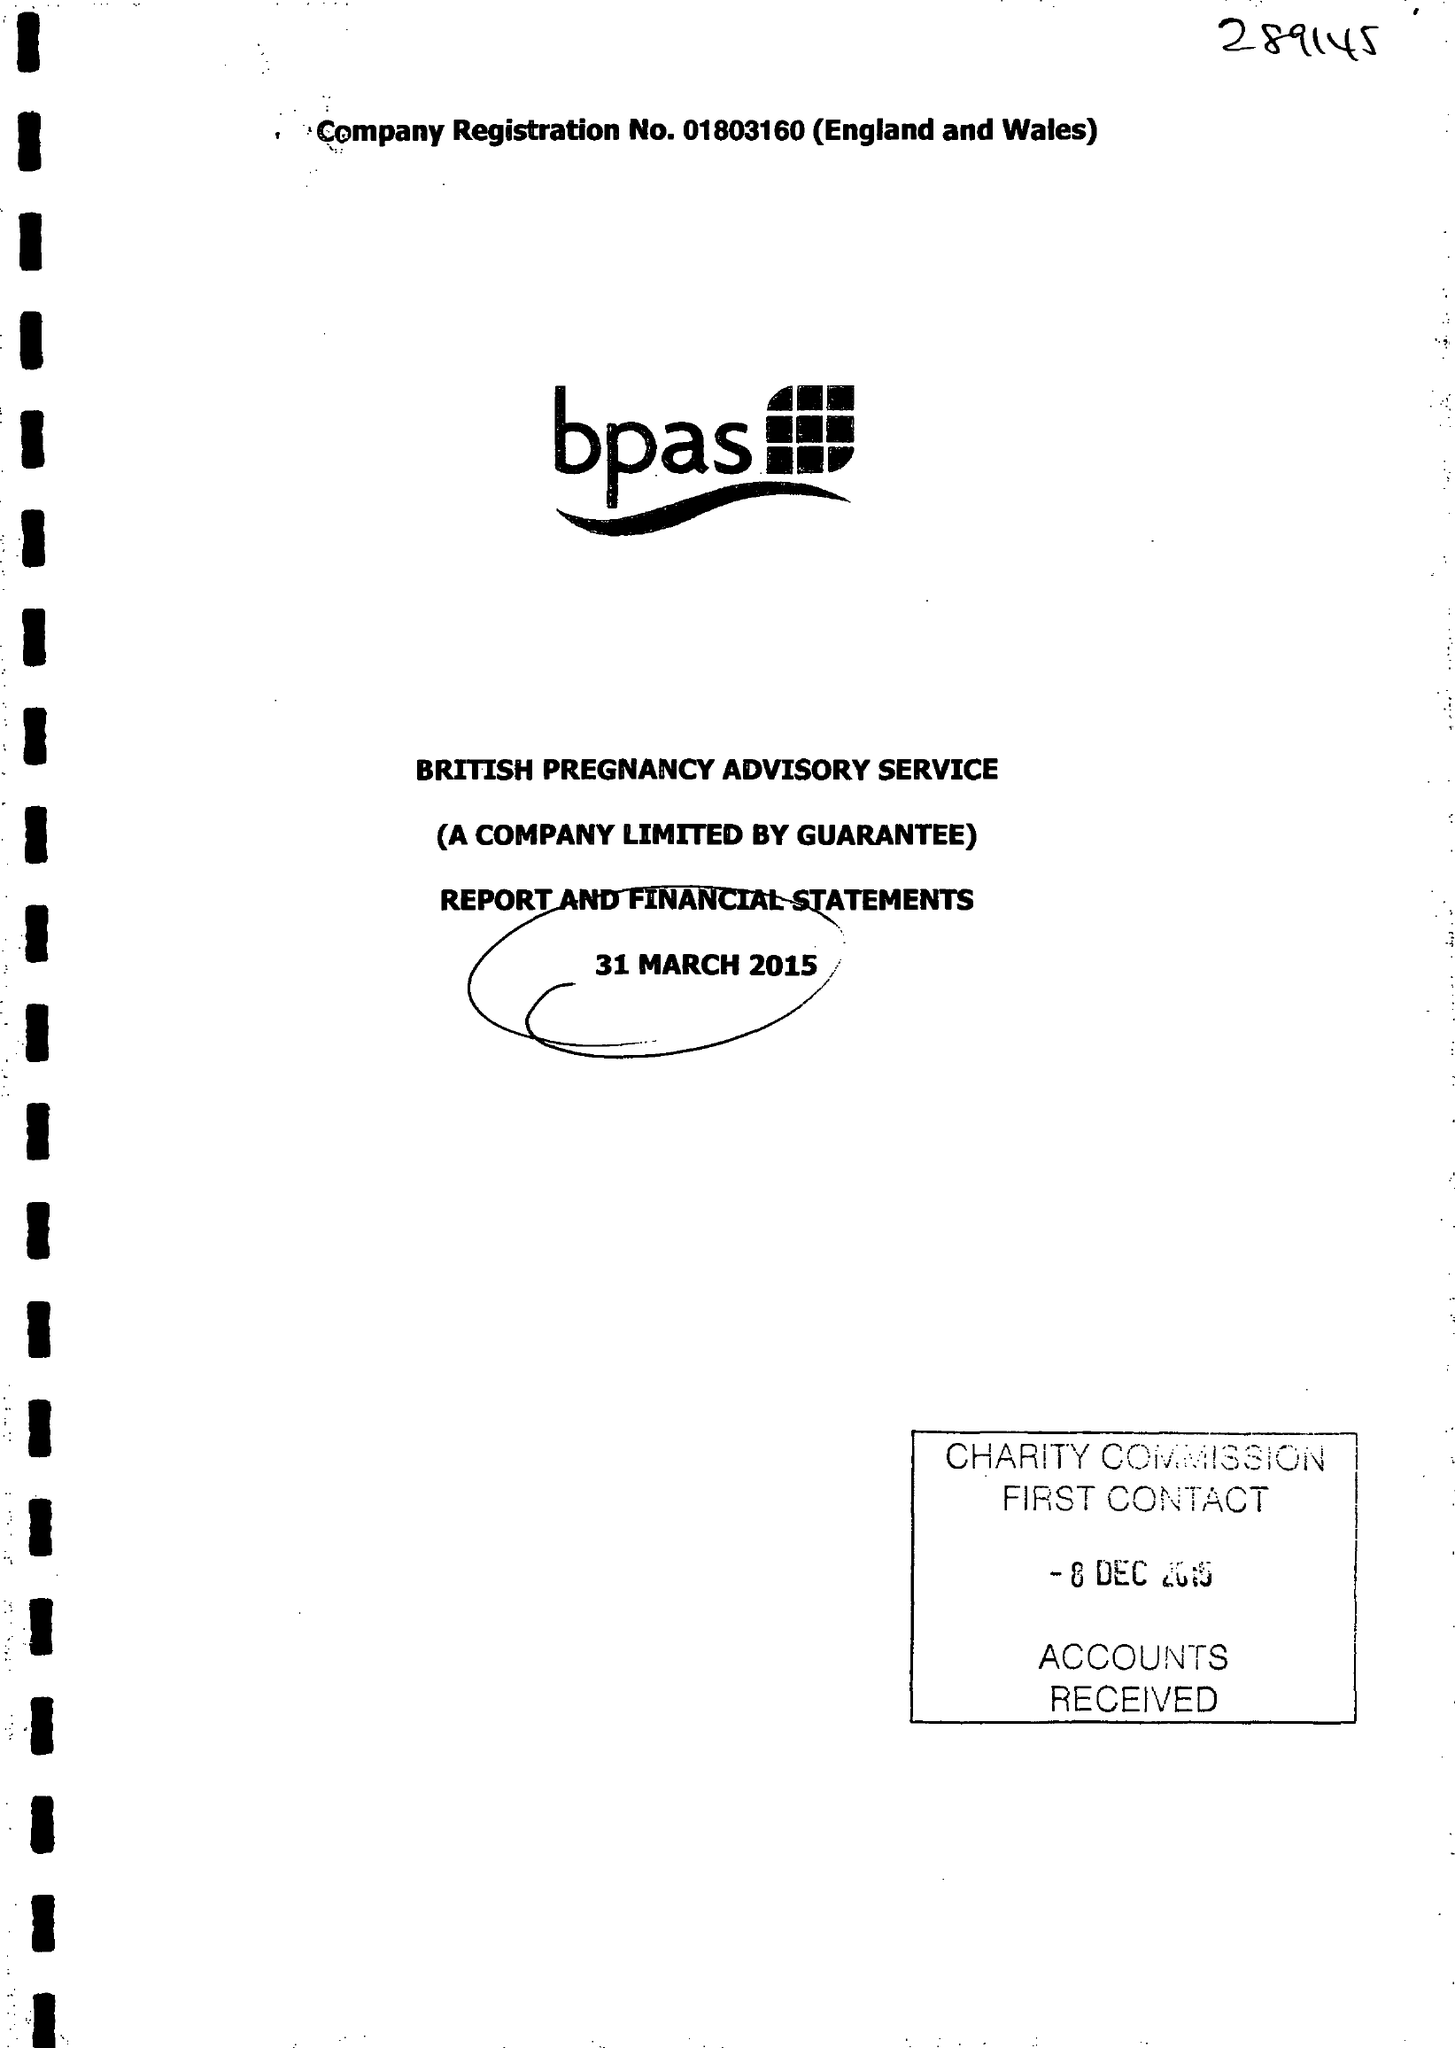What is the value for the charity_number?
Answer the question using a single word or phrase. 289145 